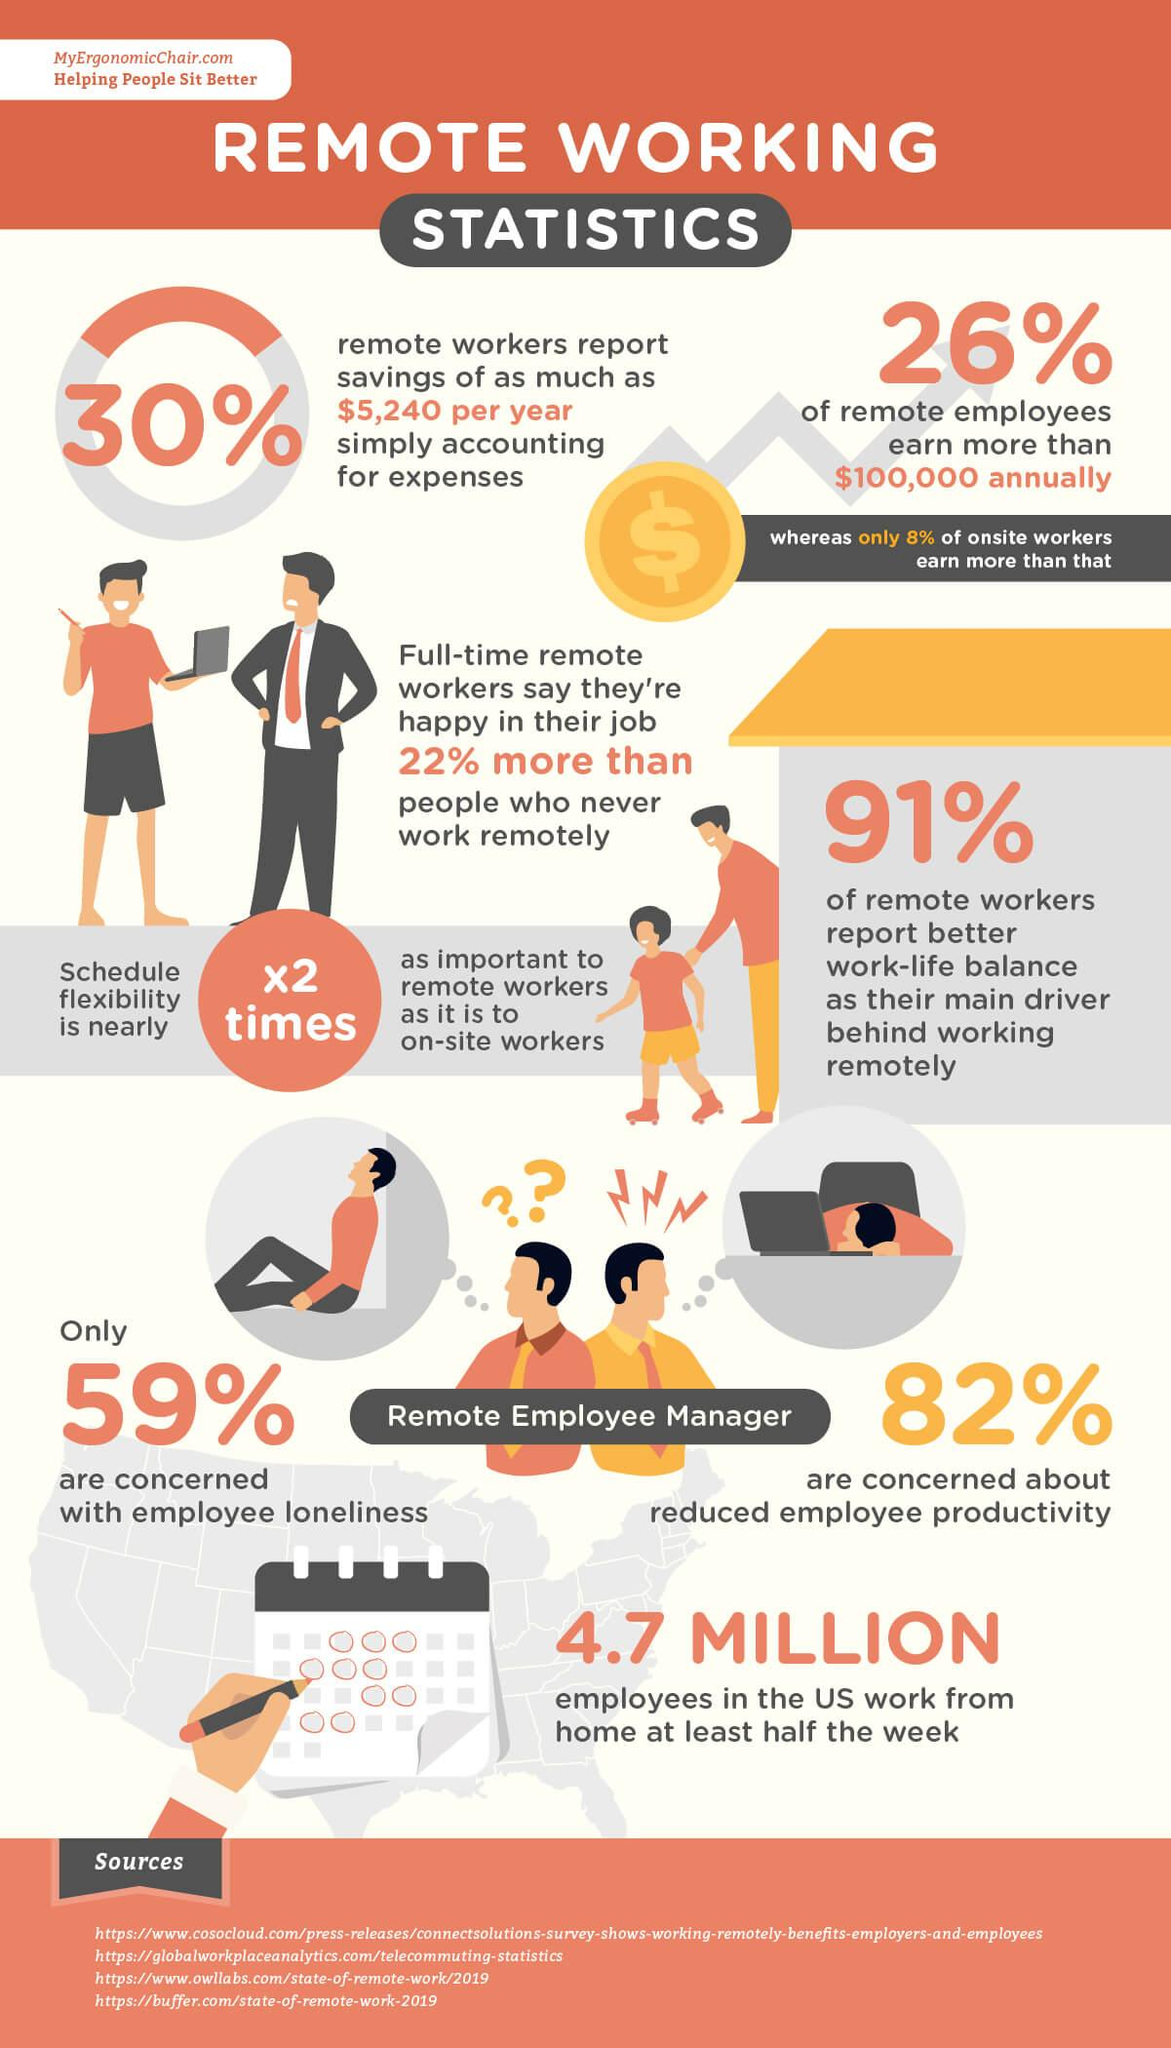Indicate a few pertinent items in this graphic. Four websites are listed as sources. Forty-one percent of the respondents are not concerned with employee loneliness. According to the data, 74% of remote employees earn less than $100,000 annually. 